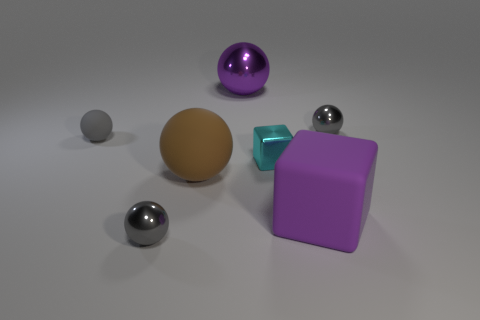Subtract all small metallic balls. How many balls are left? 3 Subtract all yellow blocks. How many gray spheres are left? 3 Subtract all brown spheres. How many spheres are left? 4 Add 3 brown balls. How many objects exist? 10 Subtract all balls. How many objects are left? 2 Subtract all blue spheres. Subtract all gray cylinders. How many spheres are left? 5 Subtract all small gray spheres. Subtract all cyan metal objects. How many objects are left? 3 Add 2 tiny gray shiny spheres. How many tiny gray shiny spheres are left? 4 Add 6 small cyan blocks. How many small cyan blocks exist? 7 Subtract 1 gray spheres. How many objects are left? 6 